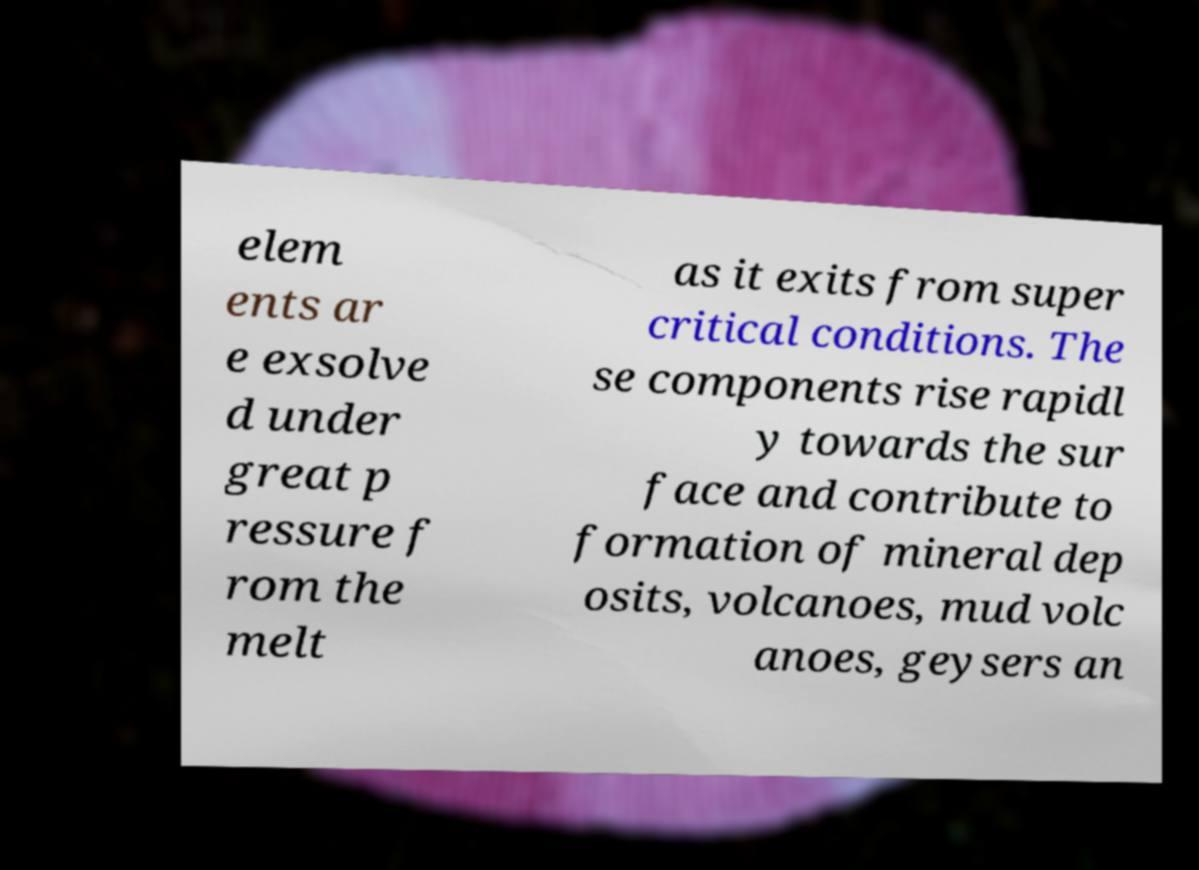Please identify and transcribe the text found in this image. elem ents ar e exsolve d under great p ressure f rom the melt as it exits from super critical conditions. The se components rise rapidl y towards the sur face and contribute to formation of mineral dep osits, volcanoes, mud volc anoes, geysers an 